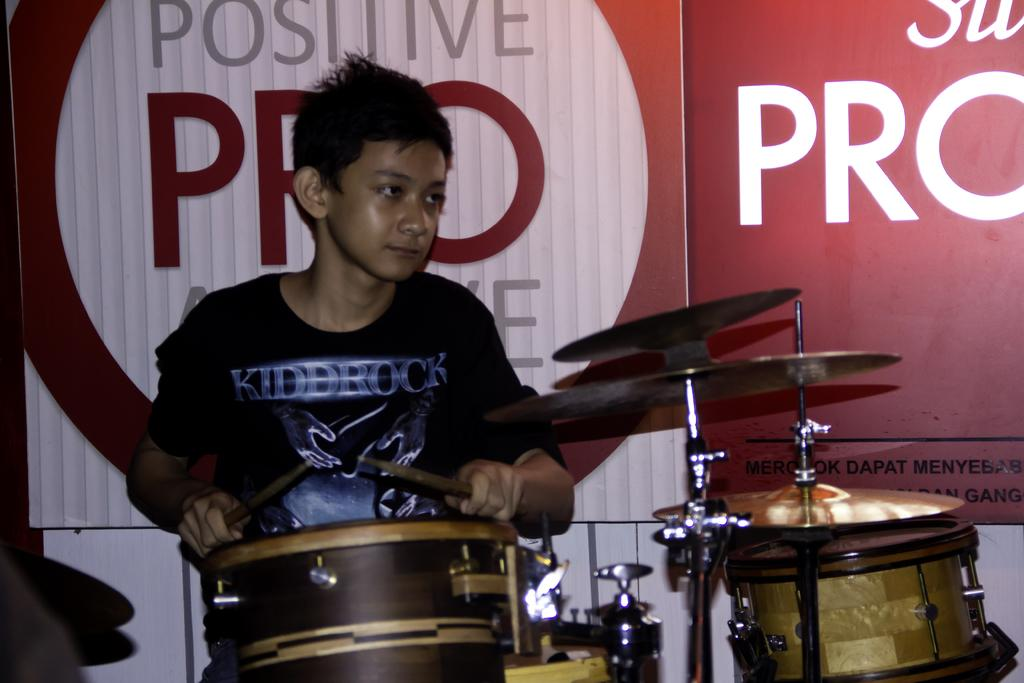Who is present in the image? There is a boy in the image. What is the boy doing or standing near in the image? The boy is next to a drum set. What type of card is the boy holding in the image? There is no card present in the image; the boy is standing next to a drum set. 